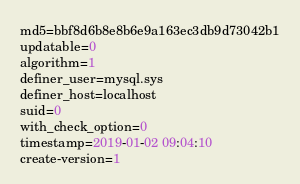Convert code to text. <code><loc_0><loc_0><loc_500><loc_500><_VisualBasic_>md5=bbf8d6b8e8b6e9a163ec3db9d73042b1
updatable=0
algorithm=1
definer_user=mysql.sys
definer_host=localhost
suid=0
with_check_option=0
timestamp=2019-01-02 09:04:10
create-version=1</code> 